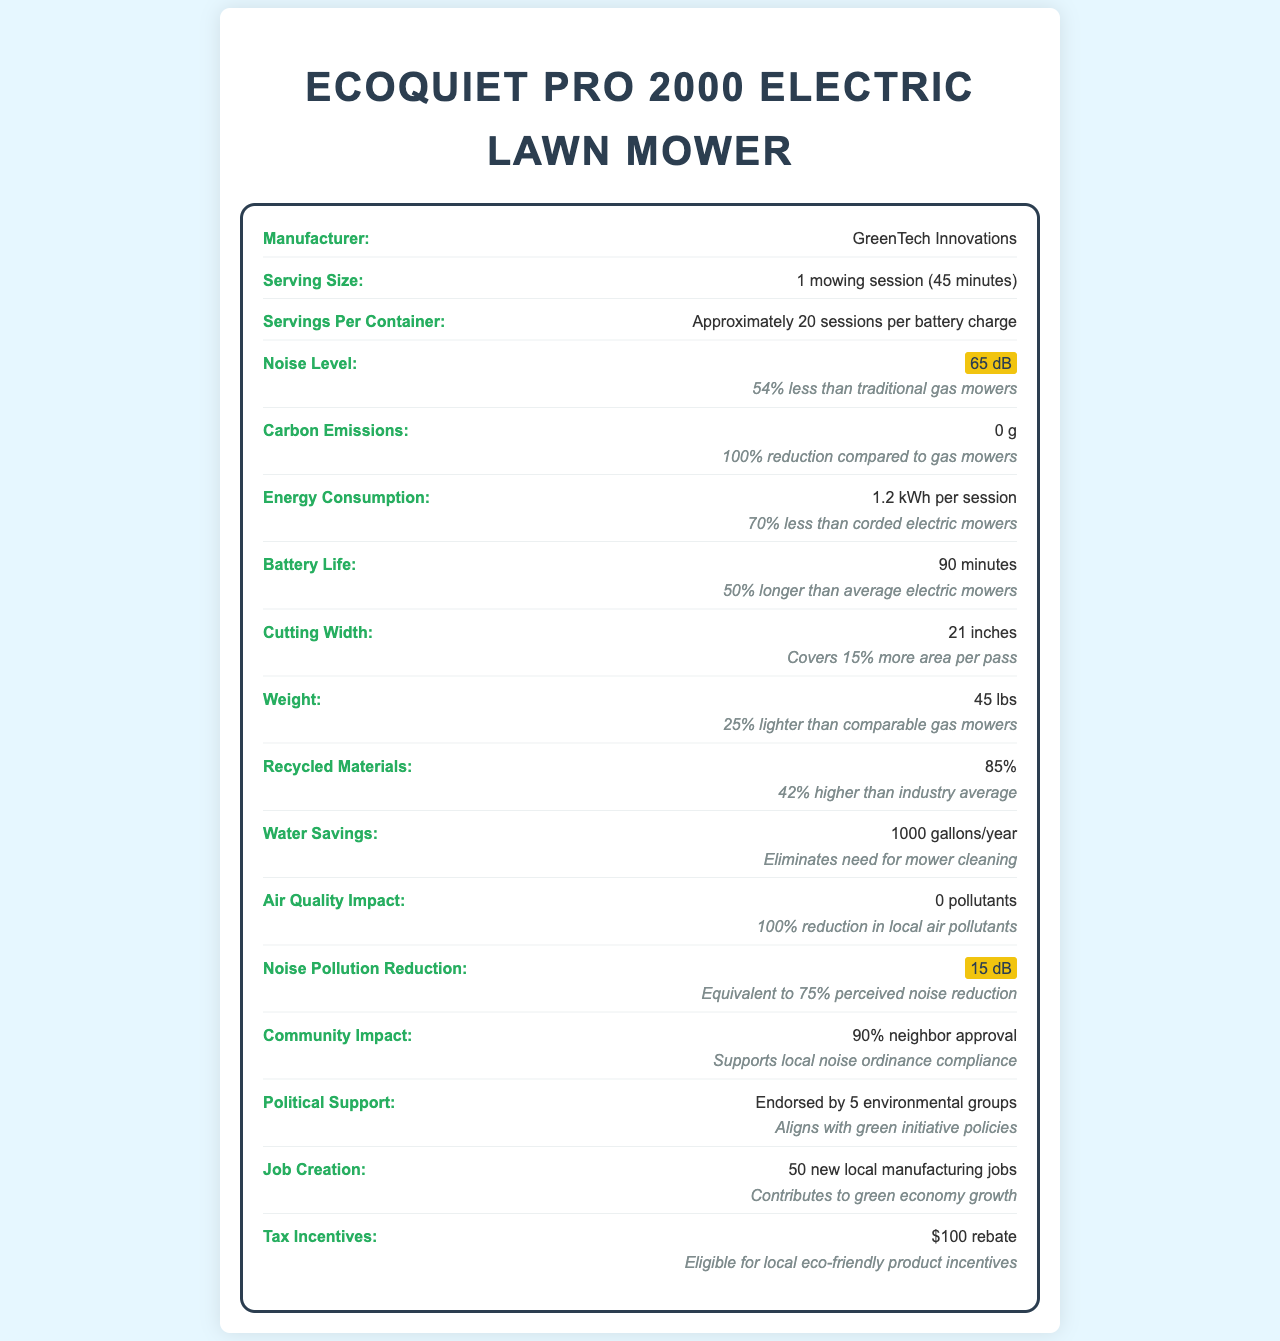what is the noise level of the EcoQuiet Pro 2000 Electric Lawn Mower? The document explicitly states the noise level as "65 dB."
Answer: 65 dB what is the battery life of this electric lawn mower? According to the document, the battery life is listed as "90 minutes."
Answer: 90 minutes how many sessions can you have per battery charge? The document specifies that there are "approximately 20 sessions per battery charge."
Answer: Approximately 20 sessions How much less noise does the EcoQuiet Pro 2000 produce compared to traditional gas mowers? According to the document, the noise level is "54% less than traditional gas mowers."
Answer: 54% less how much lighter is the EcoQuiet Pro 2000 compared to comparable gas mowers? The document mentions that the weight is "25% lighter than comparable gas mowers."
Answer: 25% lighter which environmental groups have endorsed the product? A. Sierra Club B. Environmental Defense Fund C. Greenpeace D. All of the above The document says the political support section states the product is "endorsed by 5 environmental groups."
Answer: D how much energy does the mower use per session? A. 2.0 kWh B. 1.2 kWh C. 0.8 kWh D. 1.5 kWh The document notes the energy consumption as "1.2 kWh per session."
Answer: B does this mower produce any carbon emissions? Yes/No The document clearly states the mower produces "0 g" of carbon emissions.
Answer: No how much water savings does the EcoQuiet Pro 2000 provide annually? The water savings section of the document lists "1000 gallons/year."
Answer: 1000 gallons/year is there any information on the mower's cutting width? The document states the cutting width as "21 inches."
Answer: Yes, it's 21 inches how much money can you get back from tax incentives for purchasing this mower? The document lists "$100 rebate" under tax incentives.
Answer: $100 rebate what percentage of the mower is made from recycled materials? The document specifies that "85%" of the mower is made from recycled materials.
Answer: 85% describe the main eco-friendly features of the EcoQuiet Pro 2000. This summary captures the key eco-friendly aspects of the mower highlighted in various sections such as noise level, carbon emissions, energy consumption, battery life, recycled materials, water savings, and more.
Answer: The EcoQuiet Pro 2000 is an electric lawn mower that runs silently at 65 dB, emits zero carbon emissions, uses 1.2 kWh per session which is 70% less than corded electric mowers, has a notable battery life of 90 minutes which is 50% longer than average, is made from 85% recycled materials, and eliminates the need for 1000 gallons of water annually. Additionally, it has a 21-inch cutting width, is 25% lighter than gas mowers, and reduces noise pollution by 15 dB. It also has received significant community and political endorsements. how much local manufacturing jobs were created by the EcoQuiet Pro 2000? The document states "50 new local manufacturing jobs" under job creation.
Answer: 50 new jobs how many mowing sessions can this mower handle per battery charge? The document mentions specifically "20 sessions per battery charge."
Answer: 20 sessions what are the exact five environmental groups that endorsed the product? The document mentions endorsement by "5 environmental groups" but does not specify exactly which groups.
Answer: Cannot be determined 